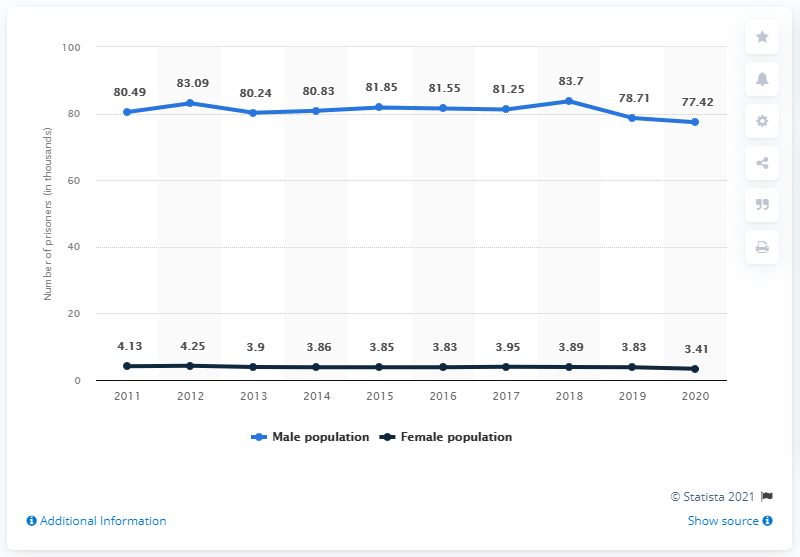Draw attention to some important aspects in this diagram. The biggest drop in the male prison population of the UK was 83.7%. In the year 2012, there were the highest number of prisoners. According to data from the UK, in 2020 there were approximately 77,420 men and 3,410 women in prison. In the year 2018, the prison population in the United Kingdom reached its highest level. 